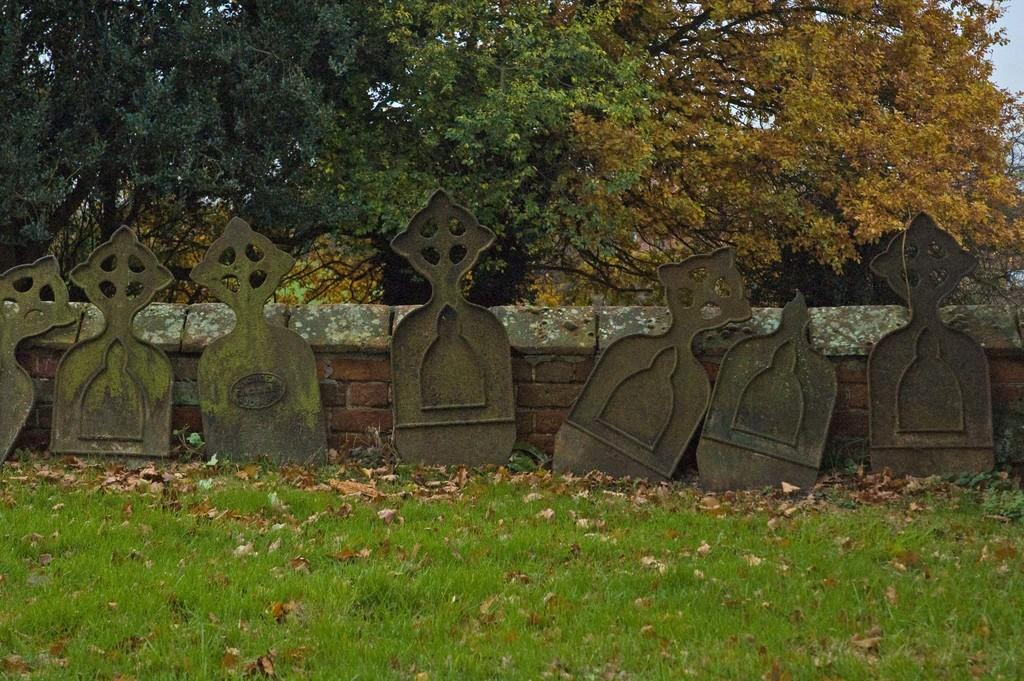What is located in the center of the image? There is a wall and metal objects in the center of the image. What can be found at the bottom of the image? A: There is grass and dry leaves at the bottom of the image. What is visible in the background of the image? There are trees and the sky visible in the background of the image. How many bags can be seen in the image? There are no bags present in the image. What type of can is visible in the image? There is no can present in the image. 